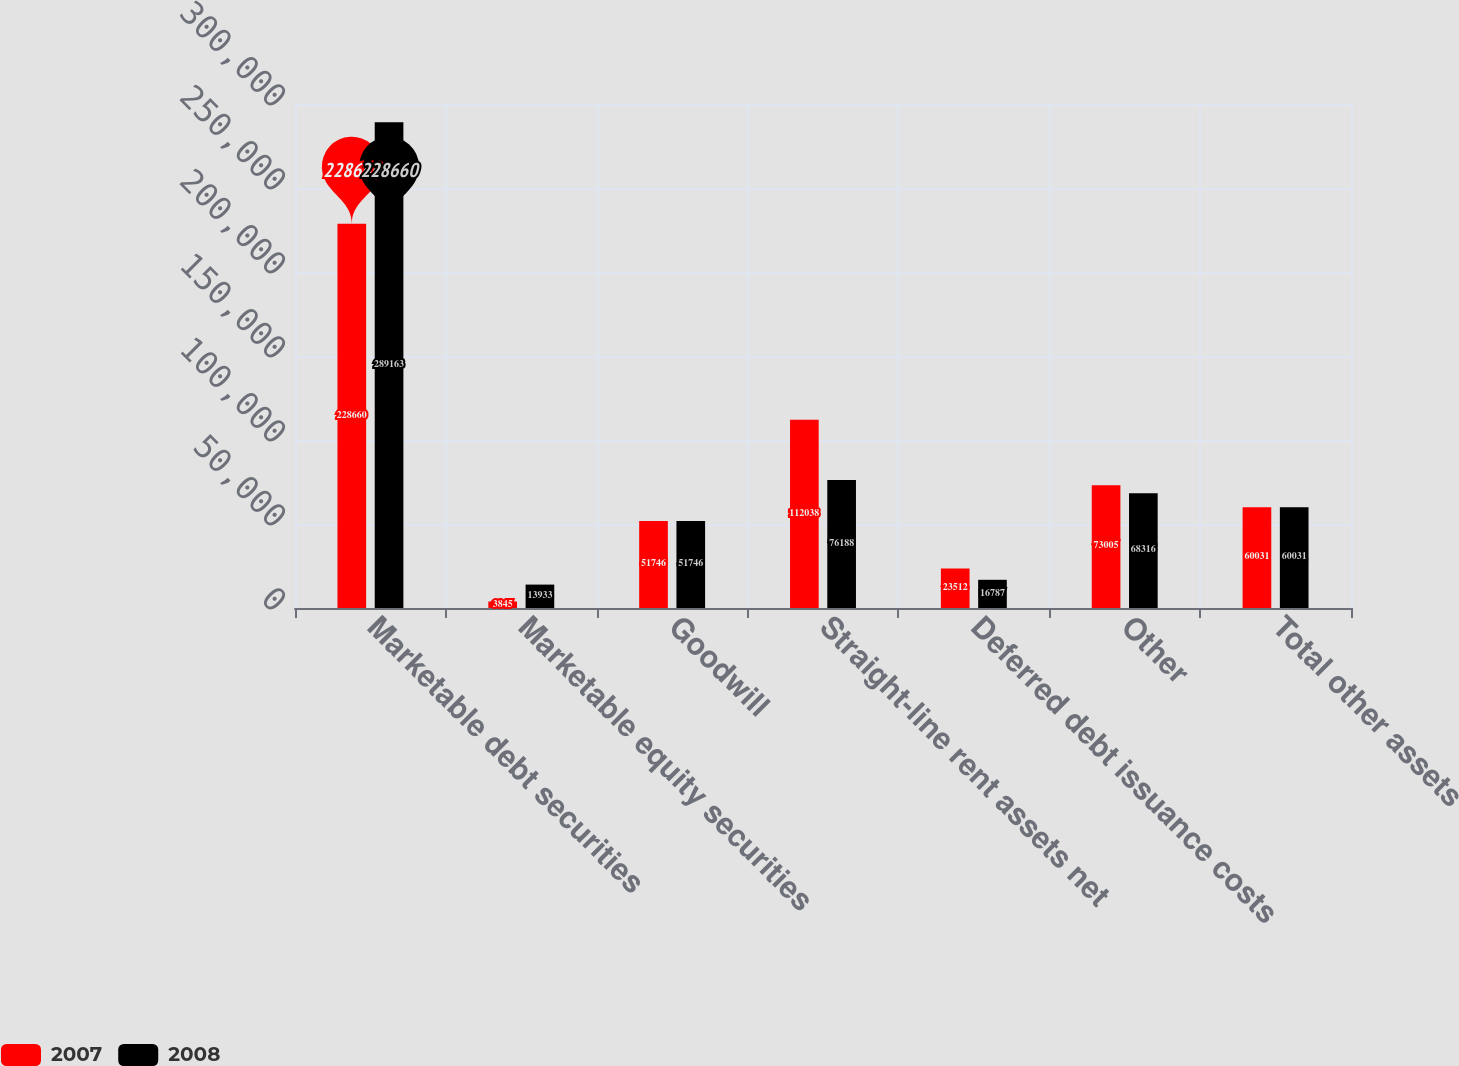<chart> <loc_0><loc_0><loc_500><loc_500><stacked_bar_chart><ecel><fcel>Marketable debt securities<fcel>Marketable equity securities<fcel>Goodwill<fcel>Straight-line rent assets net<fcel>Deferred debt issuance costs<fcel>Other<fcel>Total other assets<nl><fcel>2007<fcel>228660<fcel>3845<fcel>51746<fcel>112038<fcel>23512<fcel>73005<fcel>60031<nl><fcel>2008<fcel>289163<fcel>13933<fcel>51746<fcel>76188<fcel>16787<fcel>68316<fcel>60031<nl></chart> 